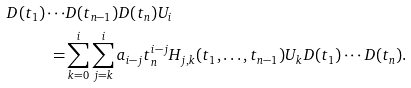<formula> <loc_0><loc_0><loc_500><loc_500>D ( t _ { 1 } ) \cdots & D ( t _ { n - 1 } ) D ( t _ { n } ) U _ { i } \\ = & \sum _ { k = 0 } ^ { i } \sum _ { j = k } ^ { i } a _ { i - j } t _ { n } ^ { i - j } H _ { j , k } ( t _ { 1 } , \dots , t _ { n - 1 } ) U _ { k } D ( t _ { 1 } ) \cdots D ( t _ { n } ) .</formula> 